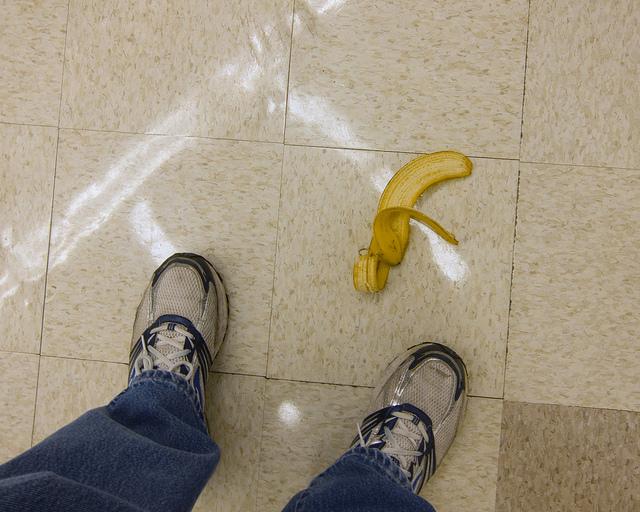Is there a banana on the ground?
Be succinct. Yes. Why is there a tile that doesn't match?
Keep it brief. Yes. What color are the shoes?
Short answer required. White. 